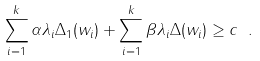Convert formula to latex. <formula><loc_0><loc_0><loc_500><loc_500>\sum _ { i = 1 } ^ { k } \alpha \lambda _ { i } \Delta _ { 1 } ( w _ { i } ) + \sum _ { i = 1 } ^ { k } \beta \lambda _ { i } \Delta ( w _ { i } ) \geq c \ .</formula> 